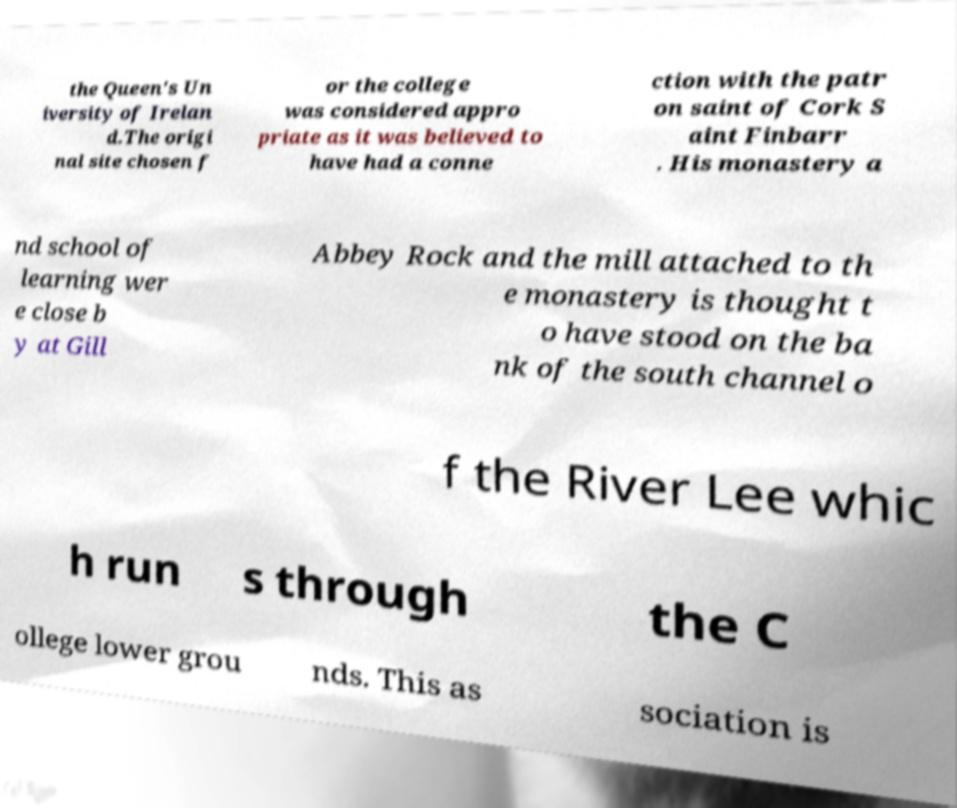Can you read and provide the text displayed in the image?This photo seems to have some interesting text. Can you extract and type it out for me? the Queen's Un iversity of Irelan d.The origi nal site chosen f or the college was considered appro priate as it was believed to have had a conne ction with the patr on saint of Cork S aint Finbarr . His monastery a nd school of learning wer e close b y at Gill Abbey Rock and the mill attached to th e monastery is thought t o have stood on the ba nk of the south channel o f the River Lee whic h run s through the C ollege lower grou nds. This as sociation is 